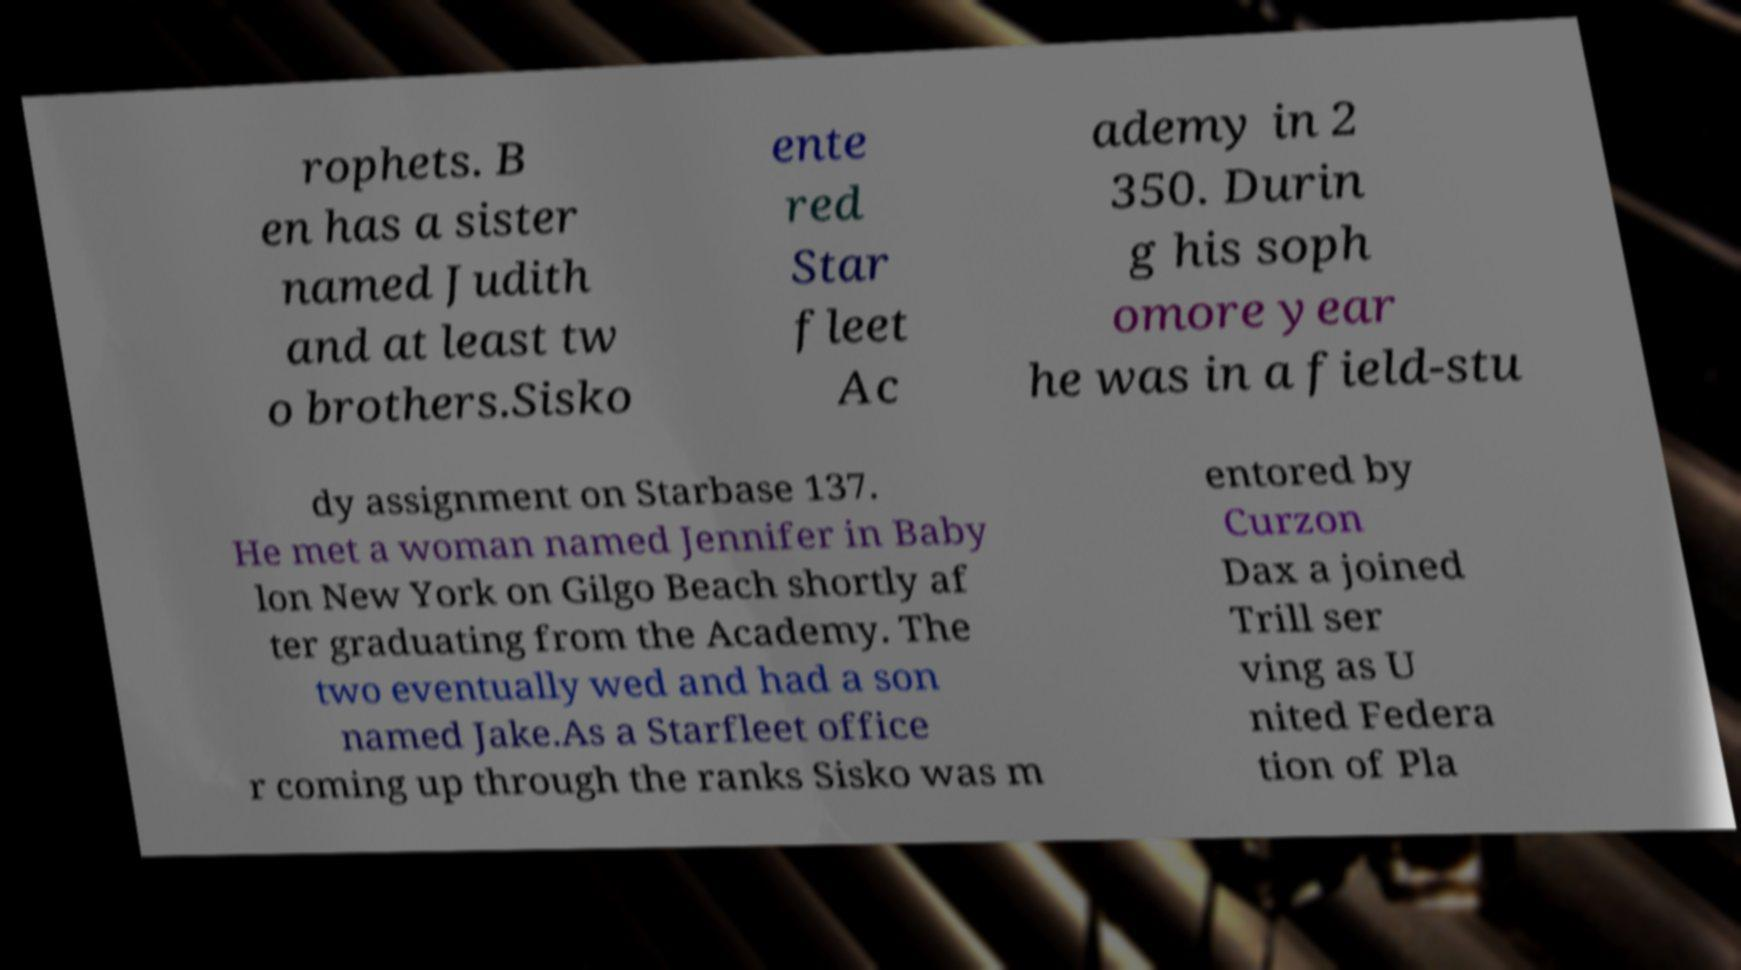What messages or text are displayed in this image? I need them in a readable, typed format. rophets. B en has a sister named Judith and at least tw o brothers.Sisko ente red Star fleet Ac ademy in 2 350. Durin g his soph omore year he was in a field-stu dy assignment on Starbase 137. He met a woman named Jennifer in Baby lon New York on Gilgo Beach shortly af ter graduating from the Academy. The two eventually wed and had a son named Jake.As a Starfleet office r coming up through the ranks Sisko was m entored by Curzon Dax a joined Trill ser ving as U nited Federa tion of Pla 